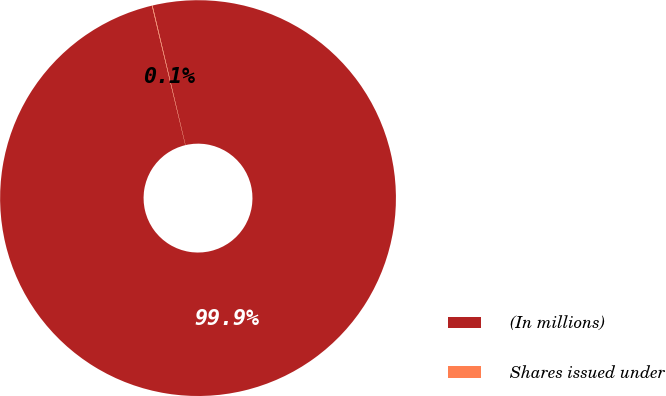Convert chart. <chart><loc_0><loc_0><loc_500><loc_500><pie_chart><fcel>(In millions)<fcel>Shares issued under<nl><fcel>99.95%<fcel>0.05%<nl></chart> 